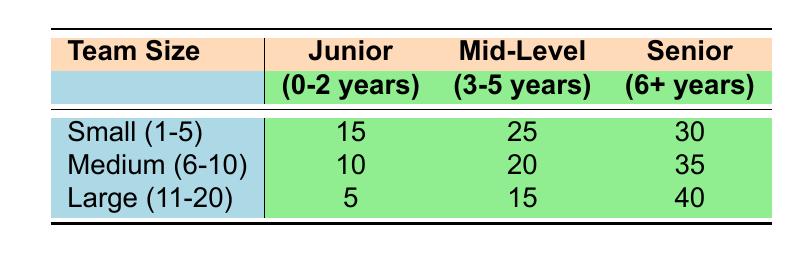What is the frequency of milestone achievements for small teams with junior-level experience? From the table, we can see that for small teams (1-5 members), the frequency of milestone achievements for junior-level experience is 15.
Answer: 15 What is the highest frequency of milestone achievements across all team sizes? By examining the table, the highest frequency observed is 40, which is for senior-level members in large teams (11-20 members).
Answer: 40 How many more milestone achievements do senior-level teams have compared to junior-level teams in medium-sized teams? In medium teams, senior members achieved 35 milestones, while junior members achieved 10. The difference is 35 - 10 = 25.
Answer: 25 Is the frequency of achievements for mid-level experience in large teams higher than in small teams? For mid-level experience, large teams have 15 achievements, and small teams have 25. Since 15 is less than 25, the statement is false.
Answer: No What is the total frequency of milestone achievements for all experience levels in small teams? To find the total for small teams, we add the frequencies: 15 (junior) + 25 (mid-level) + 30 (senior) = 70.
Answer: 70 What is the average achievement frequency for medium-sized teams? The frequencies for medium teams are 10 (junior), 20 (mid-level), and 35 (senior). The total is 10 + 20 + 35 = 65. The average is 65 divided by 3, which equals approximately 21.67.
Answer: 21.67 Are there more achievements for junior-level experience in small teams compared to large teams? In small teams, the achievement frequency for junior-level is 15, while in large teams it is 5. Since 15 is greater than 5, the statement is true.
Answer: Yes What is the frequency of milestone achievements for senior-level experience in medium-sized teams? Referring to the table, the frequency for senior-level experience in medium teams is 35.
Answer: 35 What is the combined frequency of achievements from all experience levels for large teams? For large teams, we sum the frequencies: 5 (junior) + 15 (mid-level) + 40 (senior) = 60.
Answer: 60 